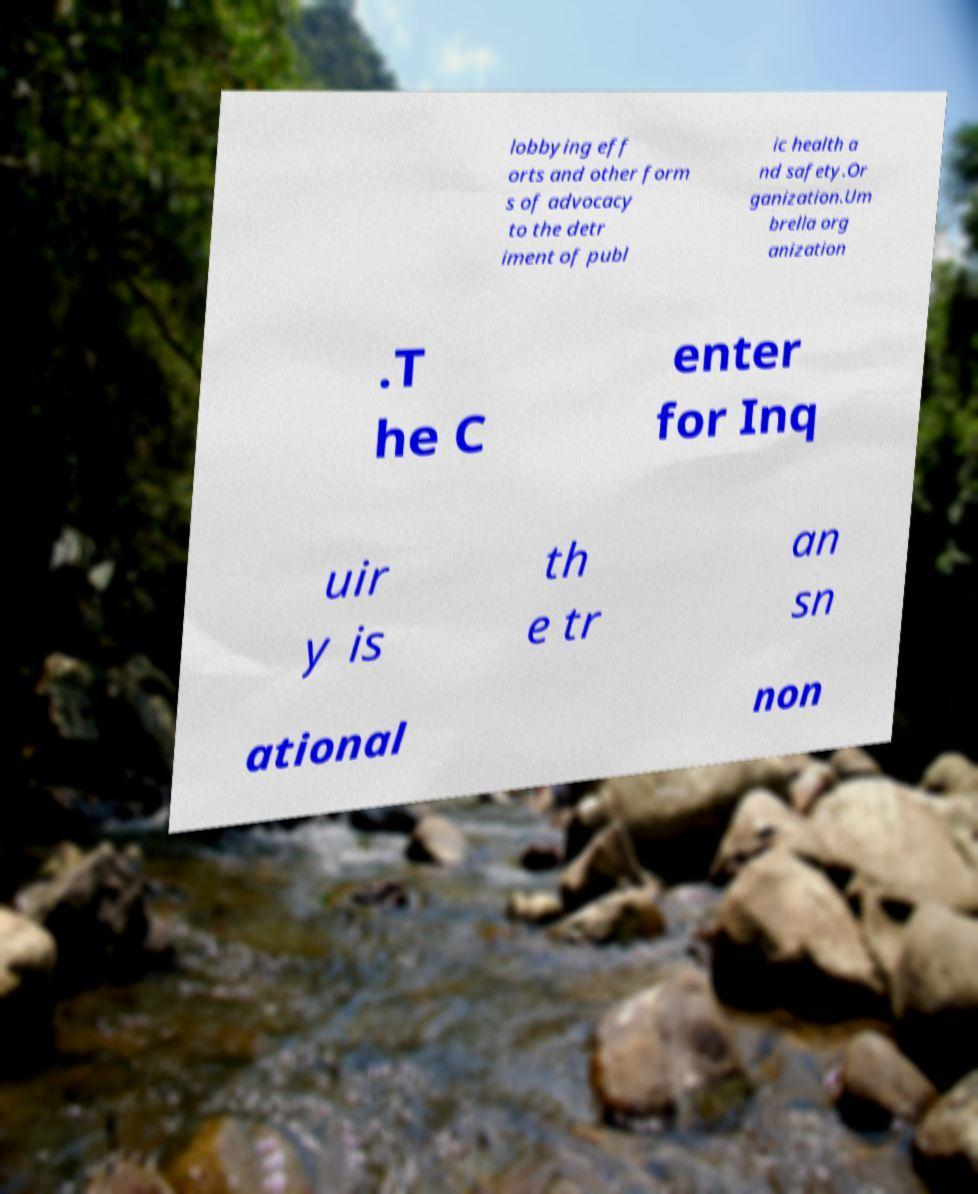Could you assist in decoding the text presented in this image and type it out clearly? lobbying eff orts and other form s of advocacy to the detr iment of publ ic health a nd safety.Or ganization.Um brella org anization .T he C enter for Inq uir y is th e tr an sn ational non 